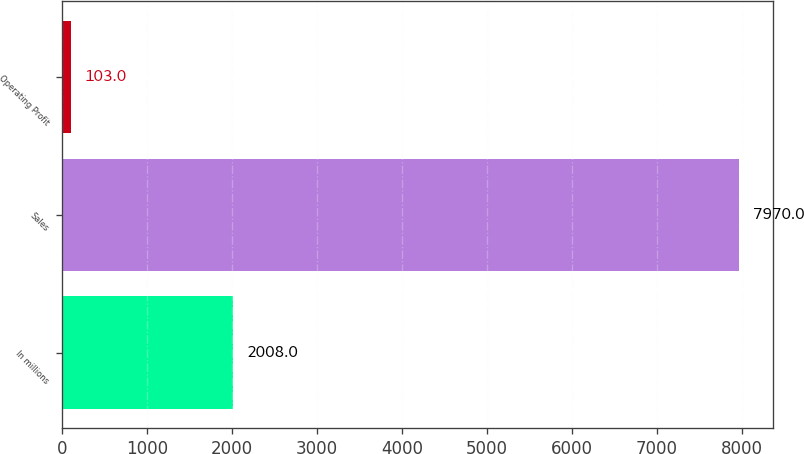Convert chart. <chart><loc_0><loc_0><loc_500><loc_500><bar_chart><fcel>In millions<fcel>Sales<fcel>Operating Profit<nl><fcel>2008<fcel>7970<fcel>103<nl></chart> 